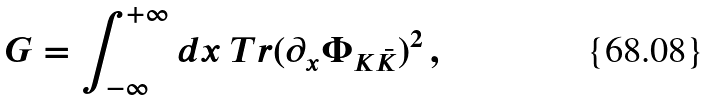Convert formula to latex. <formula><loc_0><loc_0><loc_500><loc_500>G = \int _ { - \infty } ^ { + \infty } d x \ T r ( \partial _ { x } \Phi _ { K \bar { K } } ) ^ { 2 } \, ,</formula> 